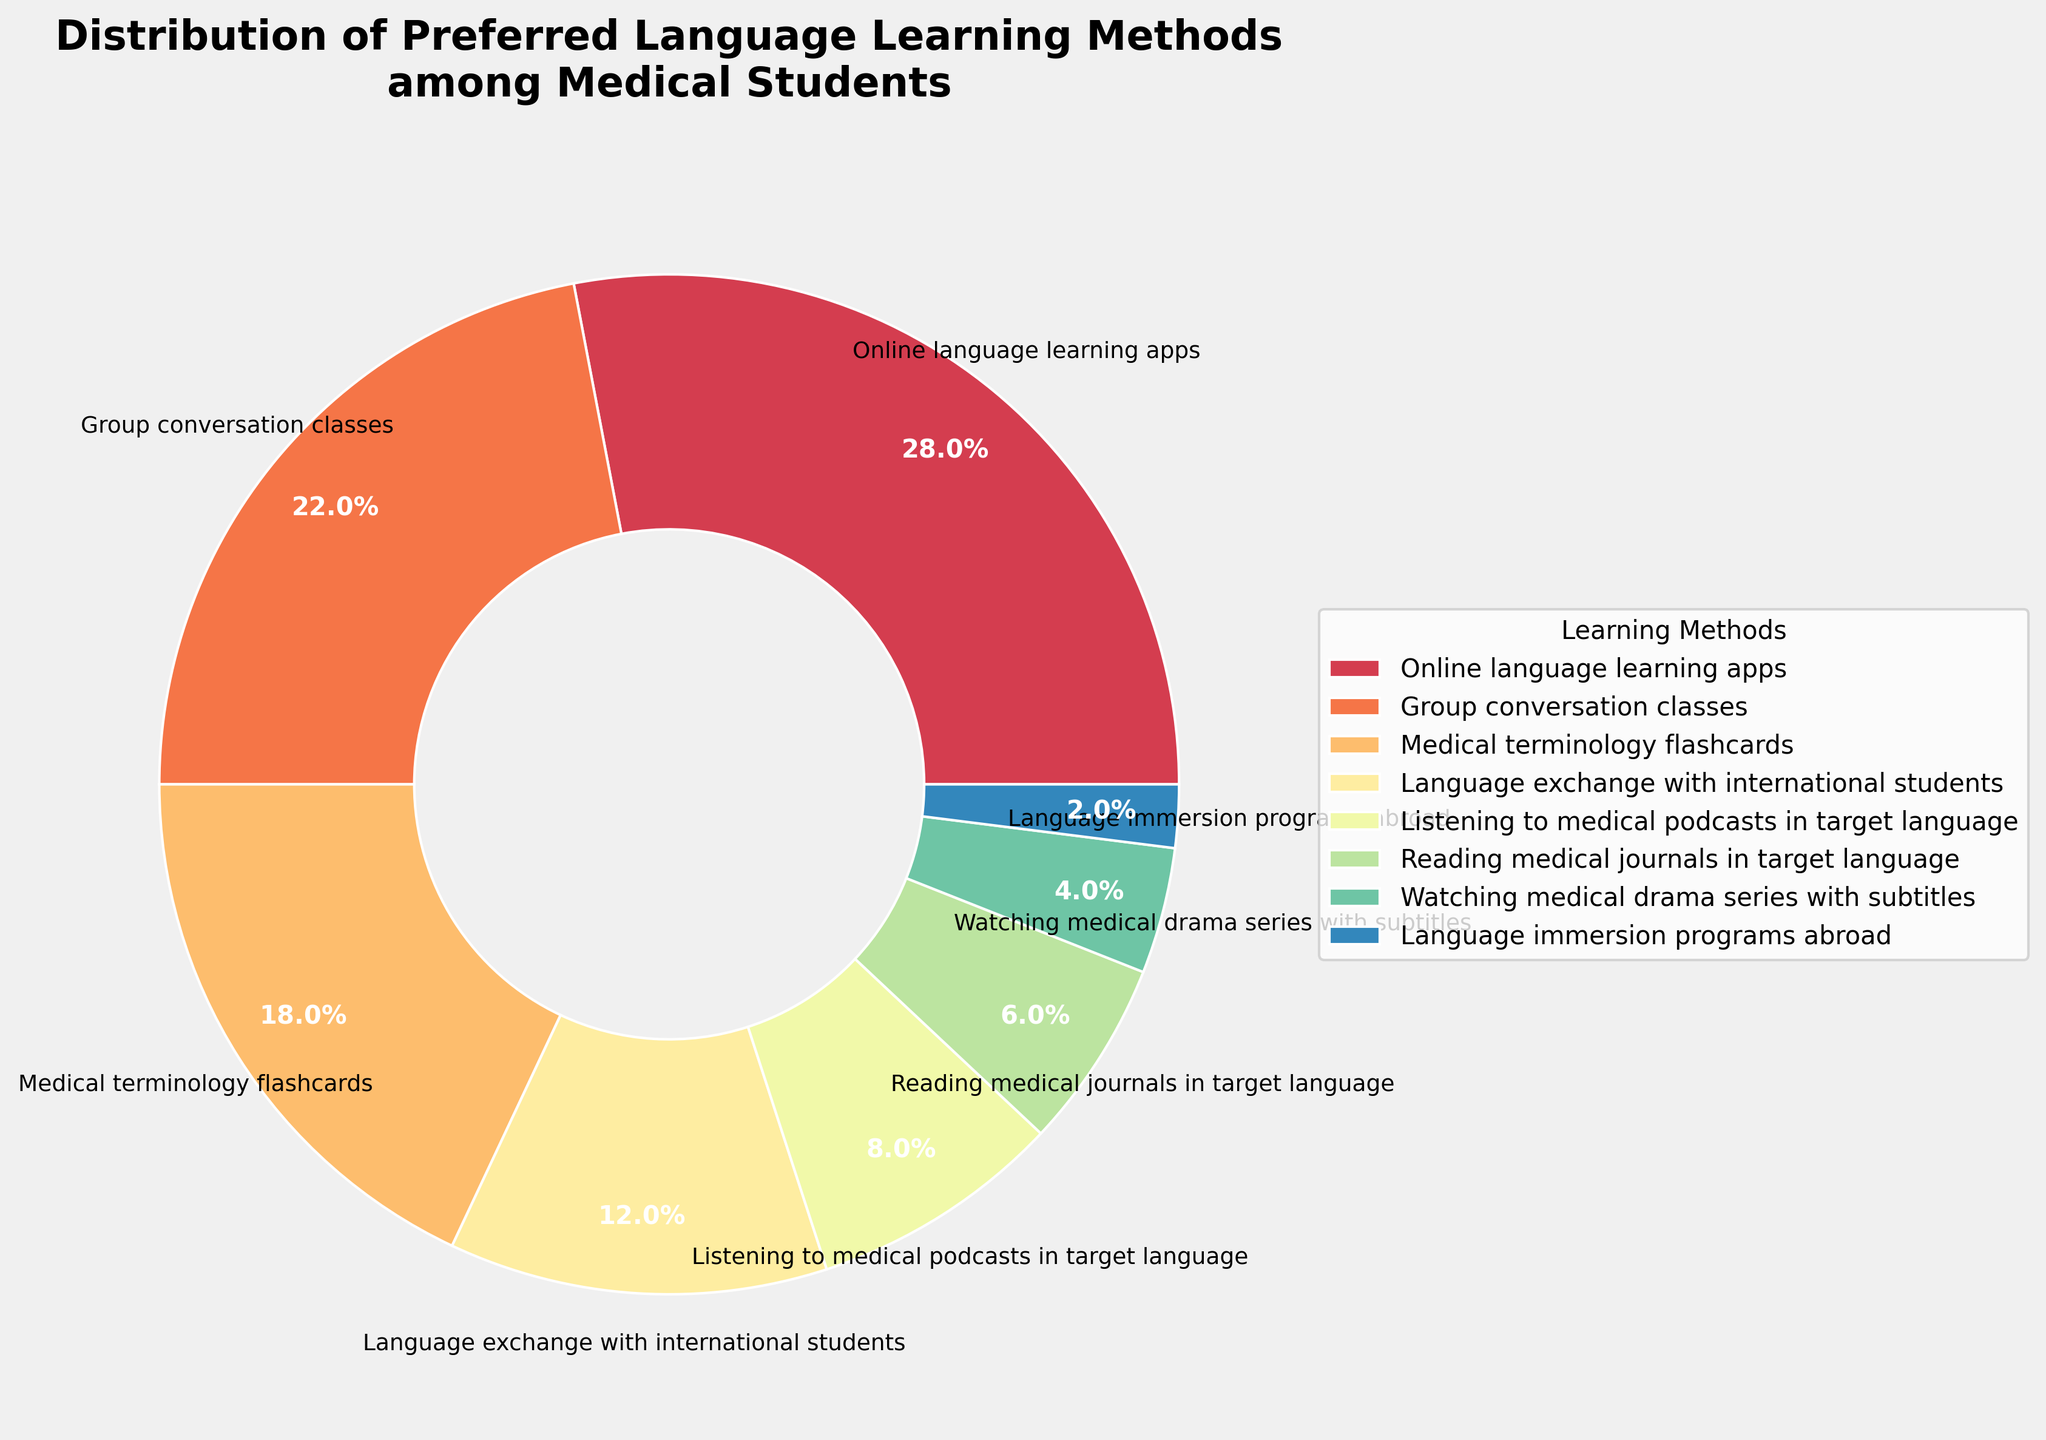Which method is preferred by the largest percentage of medical students? The method with the largest slice in the pie chart represents the highest percentage. From the chart, it's clear that the largest slice corresponds to "Online language learning apps".
Answer: Online language learning apps Which method is least preferred by medical students? The smallest slice in the pie chart represents the least preferred method. From the chart, this is "Language immersion programs abroad".
Answer: Language immersion programs abroad What is the combined percentage for "Group conversation classes" and "Medical terminology flashcards"? Adding the percentages of "Group conversation classes" (22%) and "Medical terminology flashcards" (18%) gives the combined percentage: 22 + 18 = 40%.
Answer: 40% Are there more students who prefer "Listening to medical podcasts in target language" or "Reading medical journals in target language"? Comparing the slices for "Listening to medical podcasts in target language" (8%) and "Reading medical journals in target language" (6%), the larger percentage is for podcasts.
Answer: Listening to medical podcasts in target language If we combine the preferences for "Language exchange with international students" and "Watching medical drama series with subtitles," what is the total percentage? Summing the percentages of "Language exchange with international students" (12%) and "Watching medical drama series with subtitles" (4%) gives the total percentage: 12 + 4 = 16%.
Answer: 16% Which method ranks third in preference among medical students? The pie chart shows the methods and their percentages in descending order. Starting from the largest slice (Online language learning apps) and moving to the third largest, it corresponds to "Medical terminology flashcards" with 18%.
Answer: Medical terminology flashcards Is the percentage for "Group conversation classes" greater or smaller than the sum of "Reading medical journals in target language" and "Watching medical drama series with subtitles"? The percentage for "Group conversation classes" is 22%. Summing the percentages for "Reading medical journals in the target language" (6%) and "Watching medical drama series with subtitles" (4%) gives 6 + 4 = 10%. Thus, 22% is greater than 10%.
Answer: Greater If another method were added and it became the third most preferred method with a percentage higher than "Medical terminology flashcards" but less than "Group conversation classes", what would be its likely percentage range? "Medical terminology flashcards" is 18% and "Group conversation classes" is 22%. For the new method to be third, its percentage should be between 18% and 22%.
Answer: Between 18% and 22% What is the average percentage of the top three preferred methods? The top three methods are "Online language learning apps" (28%), "Group conversation classes" (22%), and "Medical terminology flashcards" (18%). The average is calculated by summing these values and dividing by three: (28 + 22 + 18) / 3 = 68 / 3 ≈ 22.67%.
Answer: 22.67% Do "Online language learning apps" and "Listening to medical podcasts in the target language" together make up more than 30% of the distribution? Adding the percentages for "Online language learning apps" (28%) and "Listening to medical podcasts in the target language" (8%) gives: 28 + 8 = 36%. Since 36% is greater than 30%, the combined percentage exceeds 30%.
Answer: Yes 